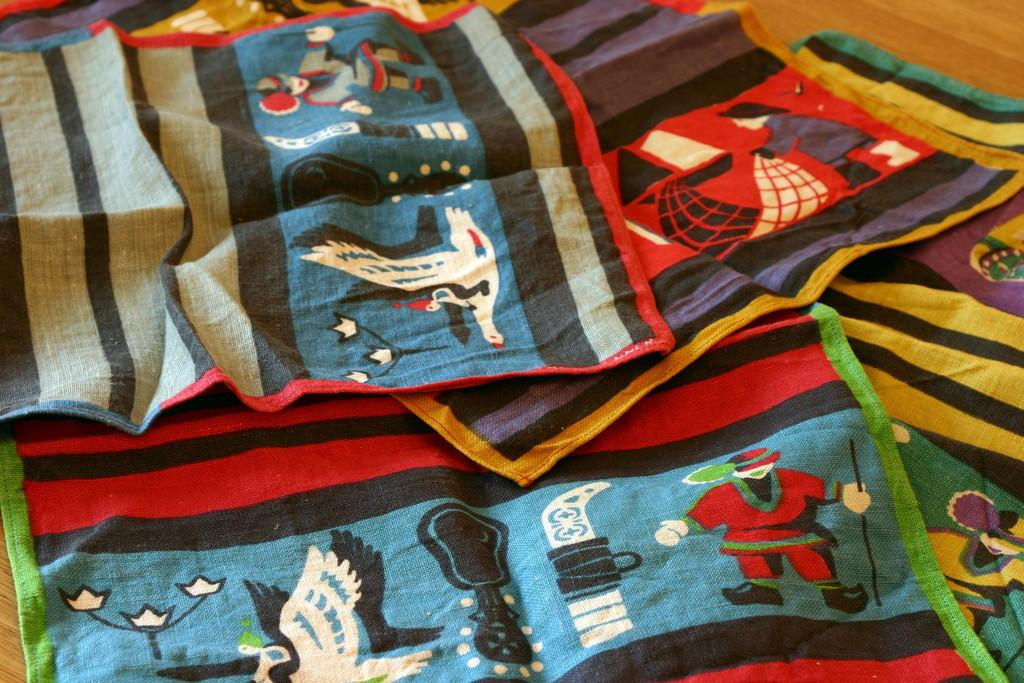What type of items are featured in the image? There are kerchiefs with designs in the image. What is the surface on which the kerchiefs are placed? The kerchiefs are on a wooden surface. Who is the creator of the shocking pizzas in the image? There are no pizzas present in the image, and therefore no creator can be identified. 